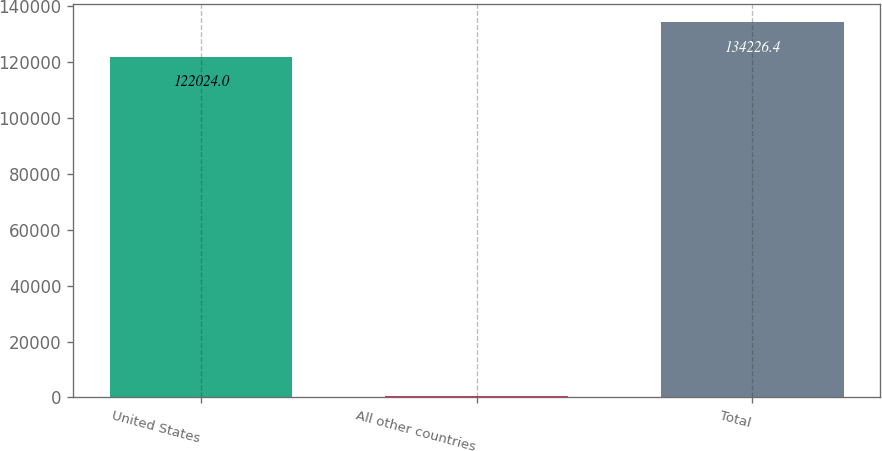<chart> <loc_0><loc_0><loc_500><loc_500><bar_chart><fcel>United States<fcel>All other countries<fcel>Total<nl><fcel>122024<fcel>552<fcel>134226<nl></chart> 